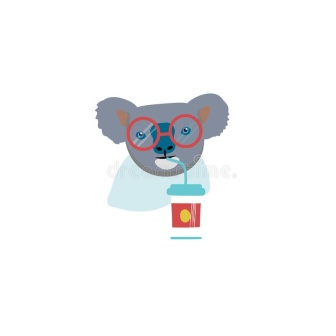Describe the following image. The image features a whimsically illustrated blue koala in the center, sporting stylish red circular glasses, which add a touch of intellect to its appearance. The koala, depicted with a slight tilt of its head to the left, engages with the viewer through its large, expressive eyes. It drinks from a vibrant red cup with a yellow lid, using a red and yellow striped straw, emphasizing a playful and colorful vibe. The white background focuses attention on the koala and its actions, enhancing the visual impact of the brightly colored elements. This representation not only captures a delightful moment but also exhibits a clean, modern illustration style that is both engaging and charming. 